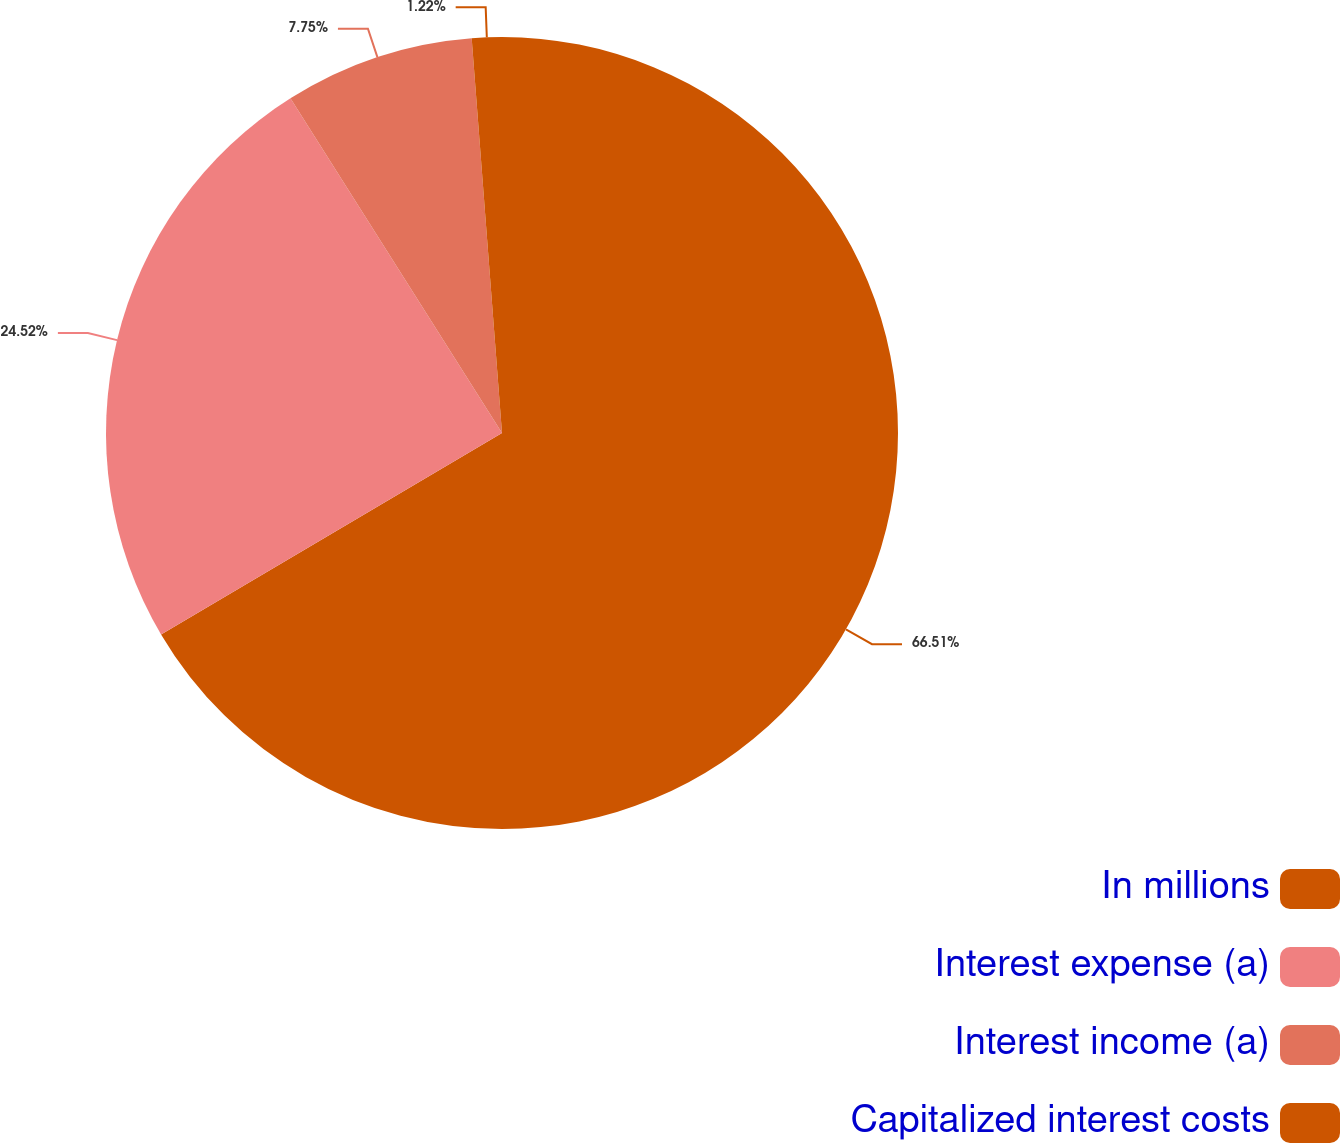<chart> <loc_0><loc_0><loc_500><loc_500><pie_chart><fcel>In millions<fcel>Interest expense (a)<fcel>Interest income (a)<fcel>Capitalized interest costs<nl><fcel>66.5%<fcel>24.52%<fcel>7.75%<fcel>1.22%<nl></chart> 